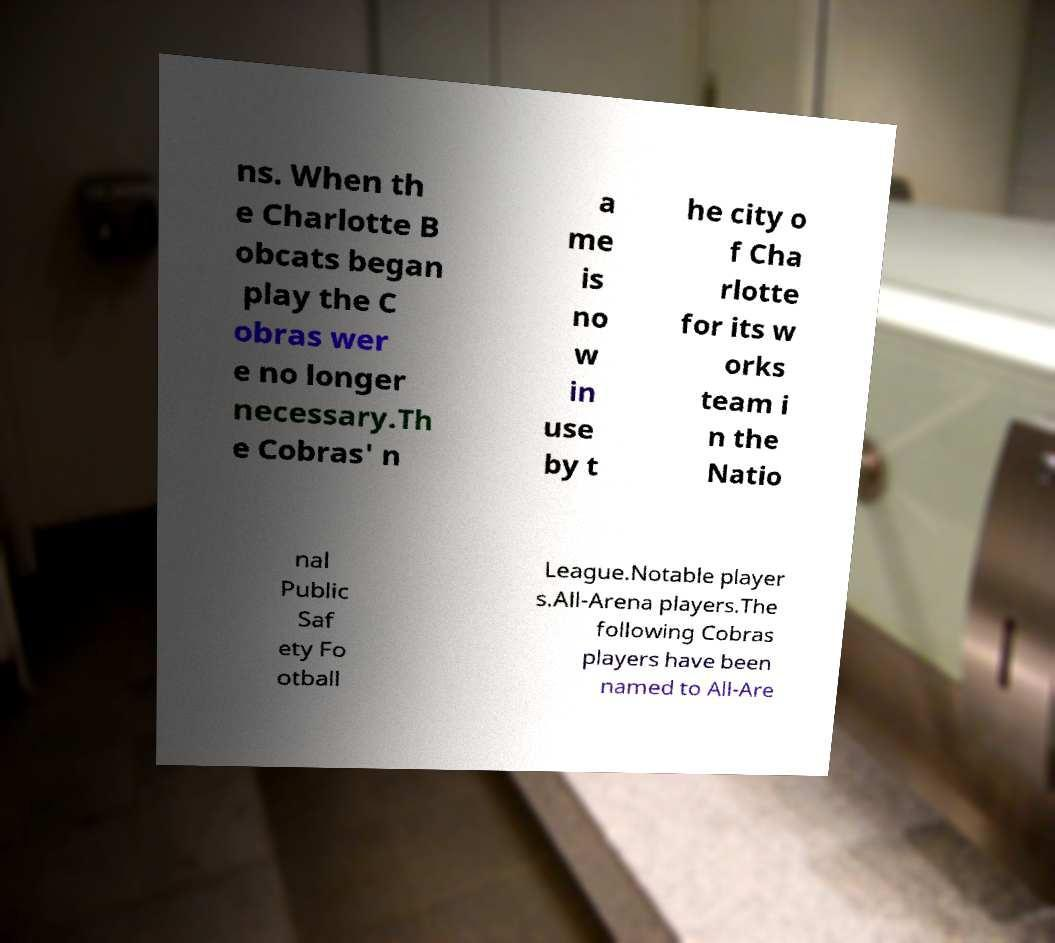Please identify and transcribe the text found in this image. ns. When th e Charlotte B obcats began play the C obras wer e no longer necessary.Th e Cobras' n a me is no w in use by t he city o f Cha rlotte for its w orks team i n the Natio nal Public Saf ety Fo otball League.Notable player s.All-Arena players.The following Cobras players have been named to All-Are 